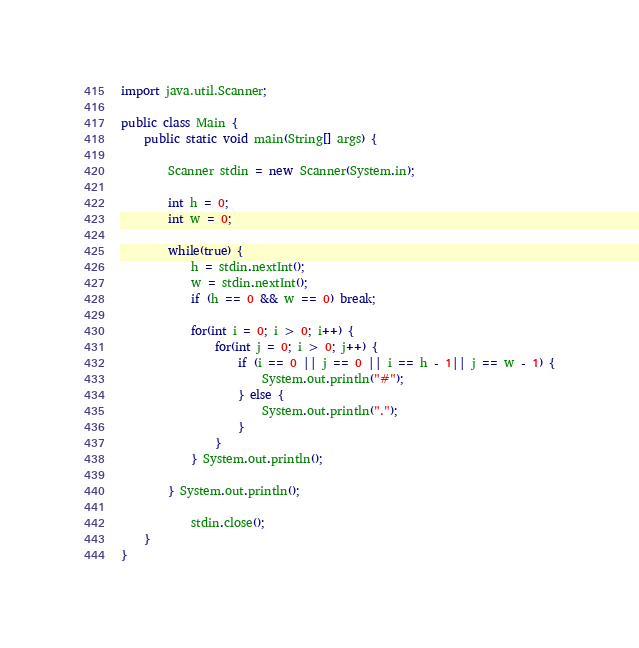<code> <loc_0><loc_0><loc_500><loc_500><_Java_>import java.util.Scanner;

public class Main {
	public static void main(String[] args) {
		
		Scanner stdin = new Scanner(System.in);
		
		int h = 0;
		int w = 0;
		
		while(true) {
			h = stdin.nextInt();
			w = stdin.nextInt();
			if (h == 0 && w == 0) break;
			
			for(int i = 0; i > 0; i++) {
				for(int j = 0; i > 0; j++) {
					if (i == 0 || j == 0 || i == h - 1|| j == w - 1) {
						System.out.println("#");
					} else {
						System.out.println(".");
					}
				}
			} System.out.println();
		
		} System.out.println();
		
			stdin.close();
	}
}</code> 